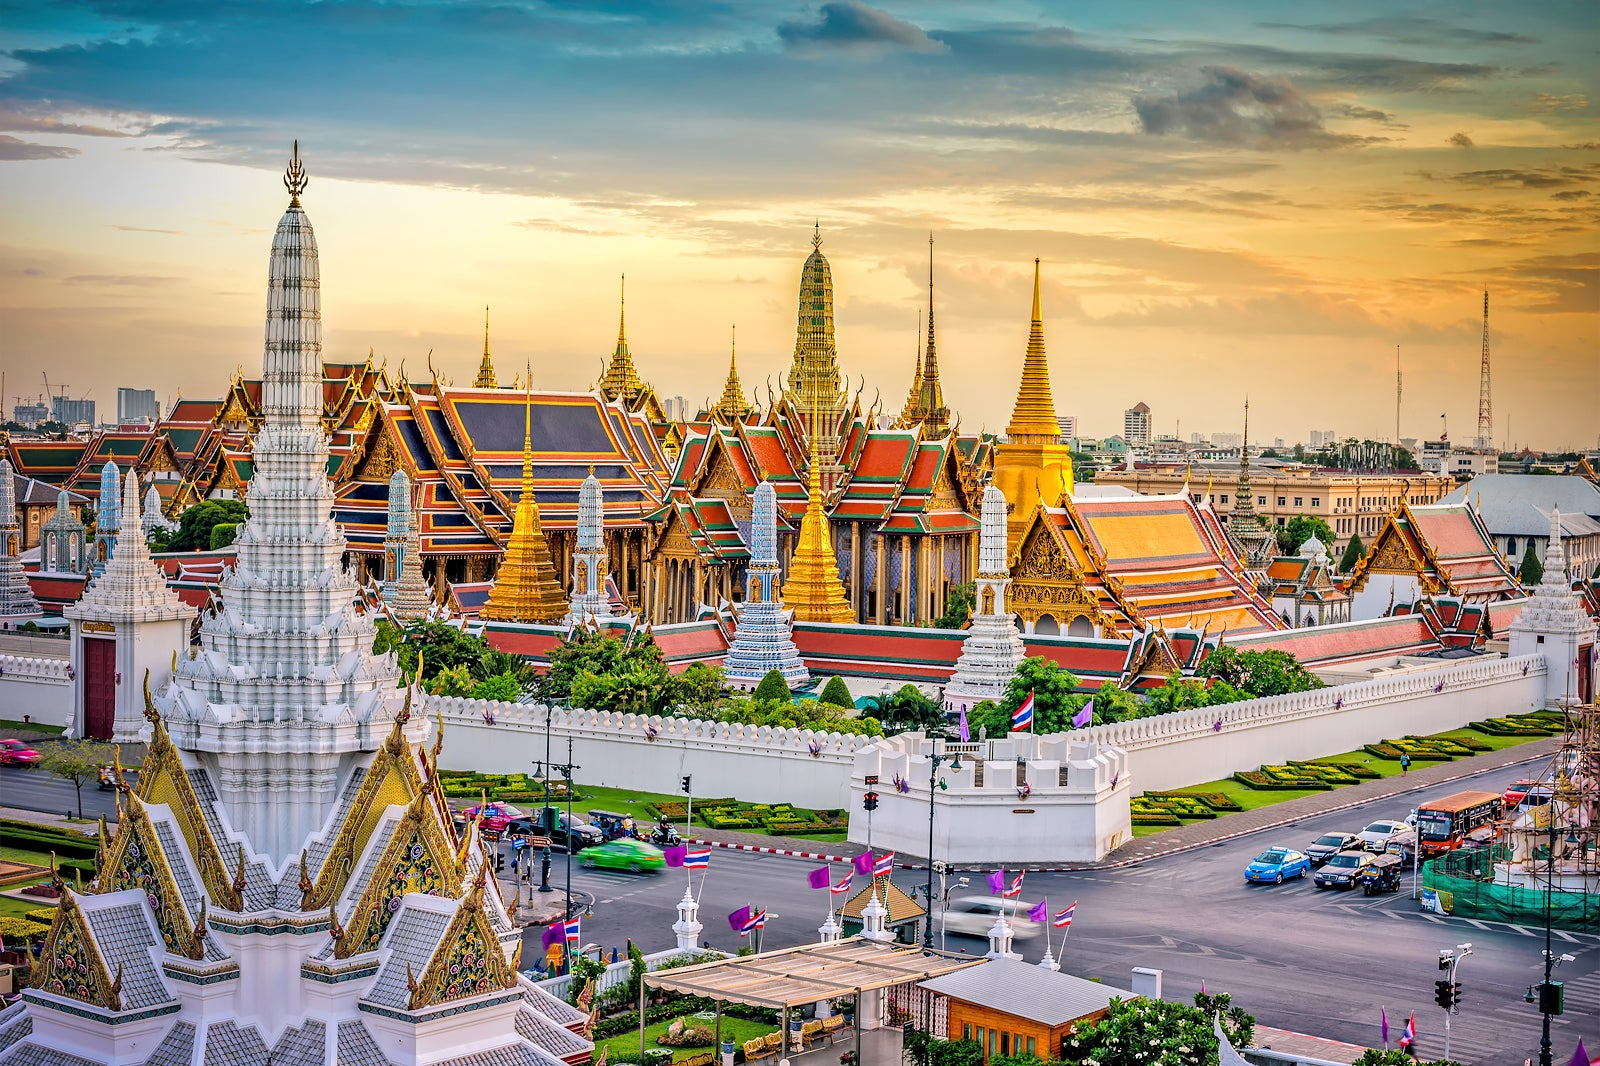How would the Grand Palace appear during a traditional Thai festival? During a traditional Thai festival, the Grand Palace would be a vibrant spectacle of color and activity. The ornate spires and roofs would glisten even more brightly in the sunlight, adorned with additional decorations. Festival banners, flowers, and intricate lanterns would line the walls and pathways. The air would be filled with the sounds of traditional music and the aroma of Thai cuisine from food stalls. Monks in saffron robes and people in traditional attire would move through the complex, participating in rituals and celebrations. The palace would be alive with the spirit of festivity, blending reverence with joyful celebration. 